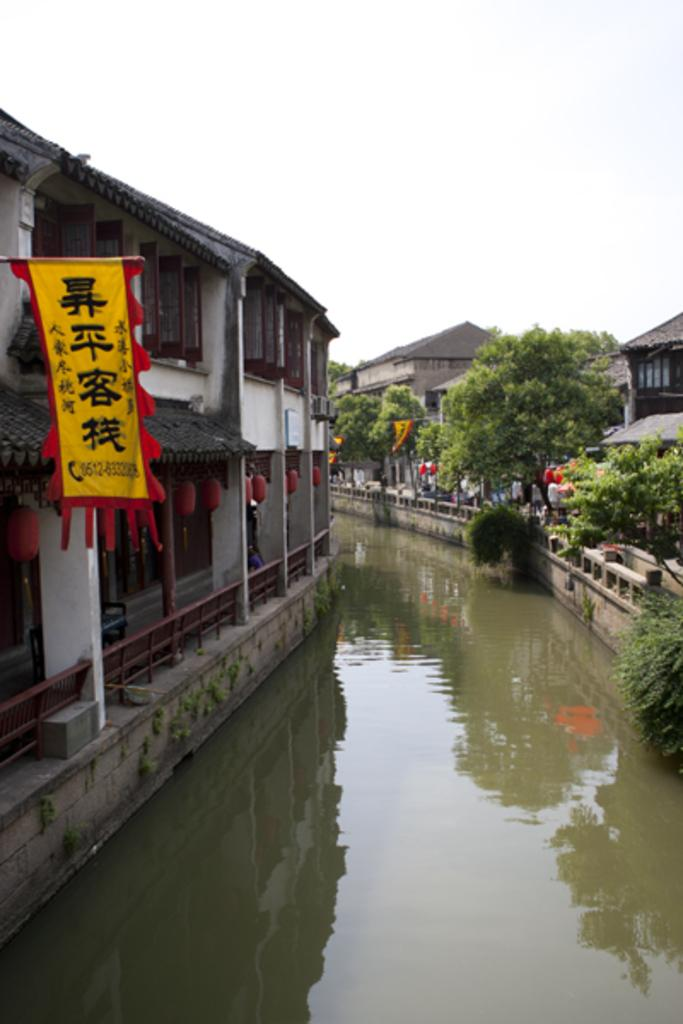What type of structures can be seen in the image? There are buildings in the image. What natural feature is present between the buildings? There is a river between the buildings. What type of vegetation is on the right side of the image? There are many trees on the right side of the image. How are the trees positioned in relation to the buildings? The trees are in front of the buildings. Can you see a cave behind the trees in the image? There is no cave visible behind the trees in the image. What type of neck accessory is the airplane wearing in the image? There is no airplane present in the image, so it cannot be wearing any neck accessory. 